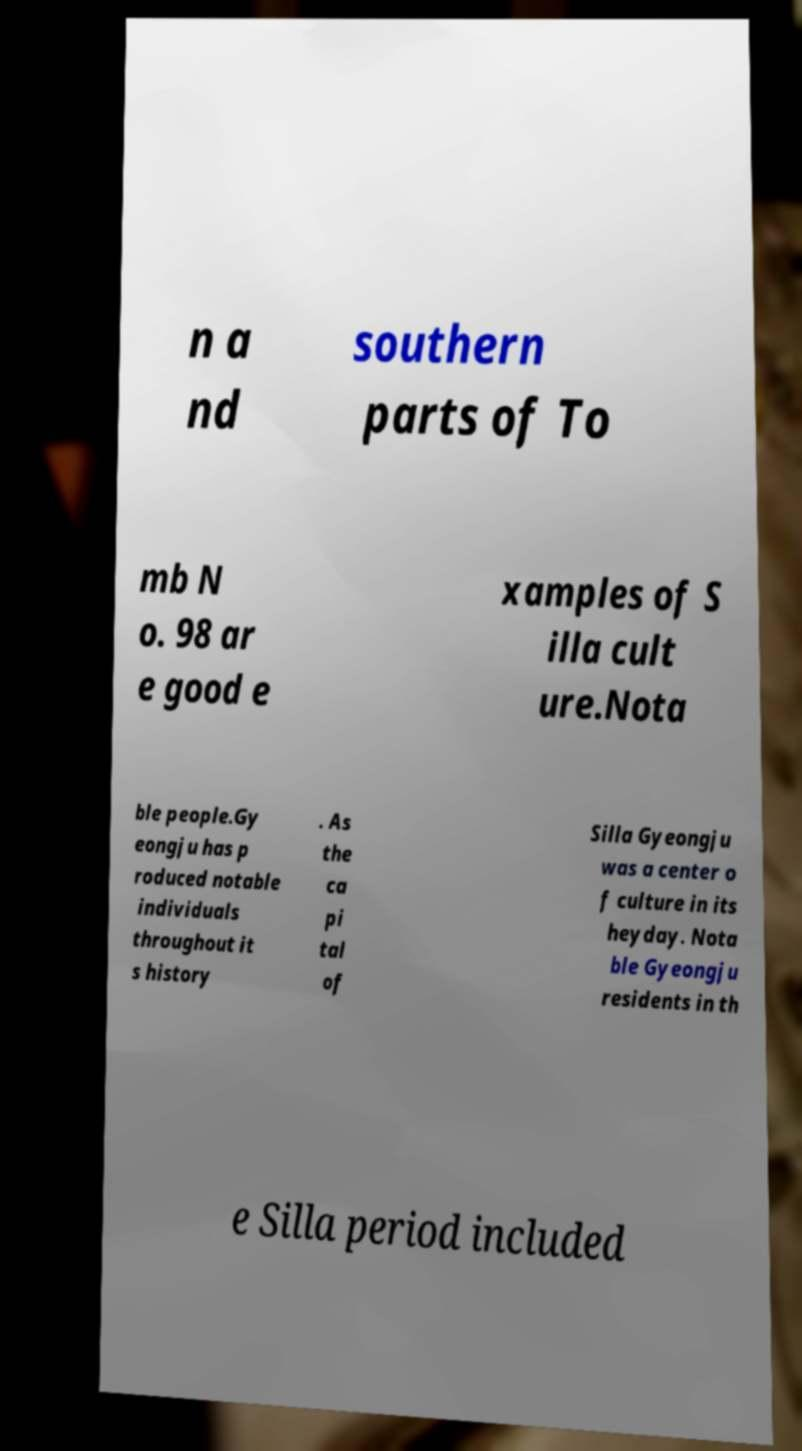I need the written content from this picture converted into text. Can you do that? n a nd southern parts of To mb N o. 98 ar e good e xamples of S illa cult ure.Nota ble people.Gy eongju has p roduced notable individuals throughout it s history . As the ca pi tal of Silla Gyeongju was a center o f culture in its heyday. Nota ble Gyeongju residents in th e Silla period included 